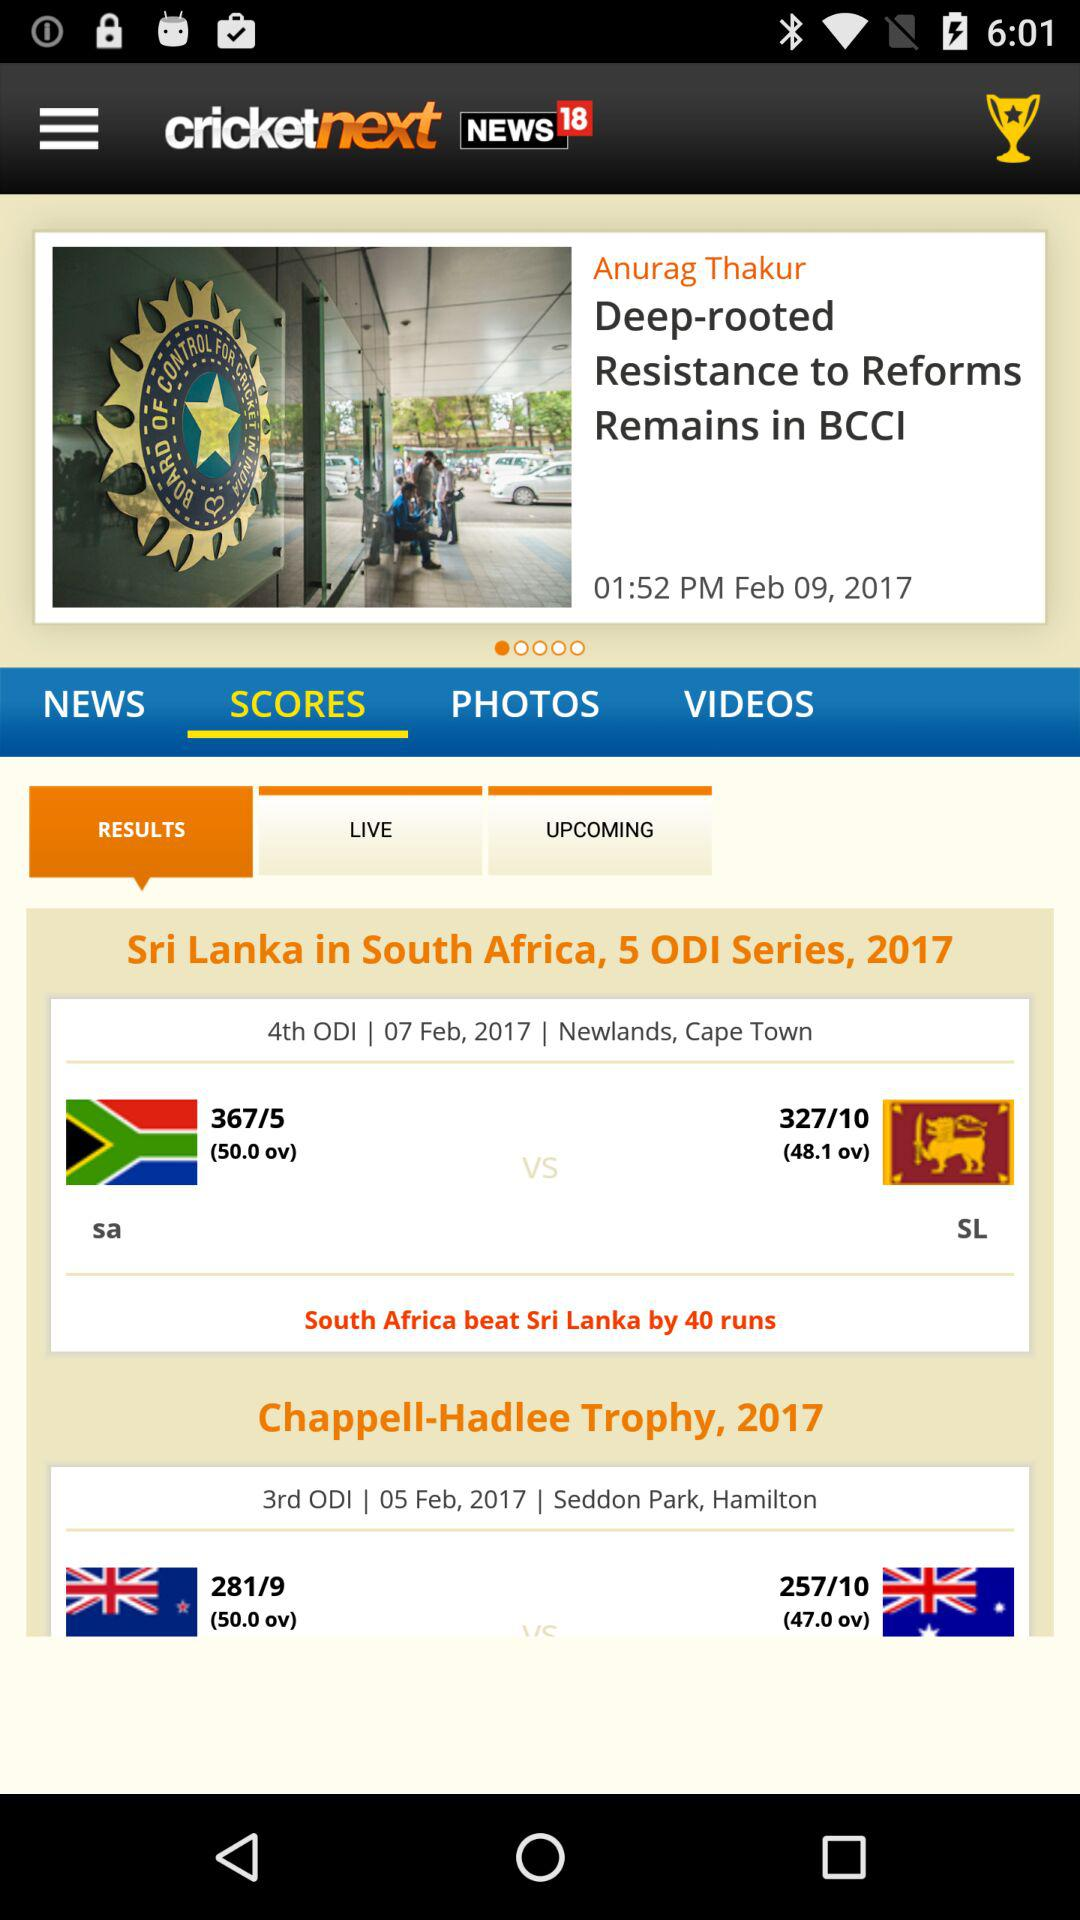How many more runs did South Africa score than Sri Lanka in the 4th ODI?
Answer the question using a single word or phrase. 40 